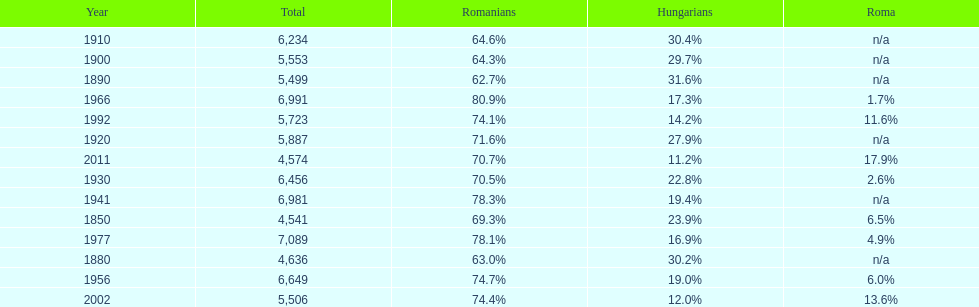Which year is previous to the year that had 74.1% in romanian population? 1977. 